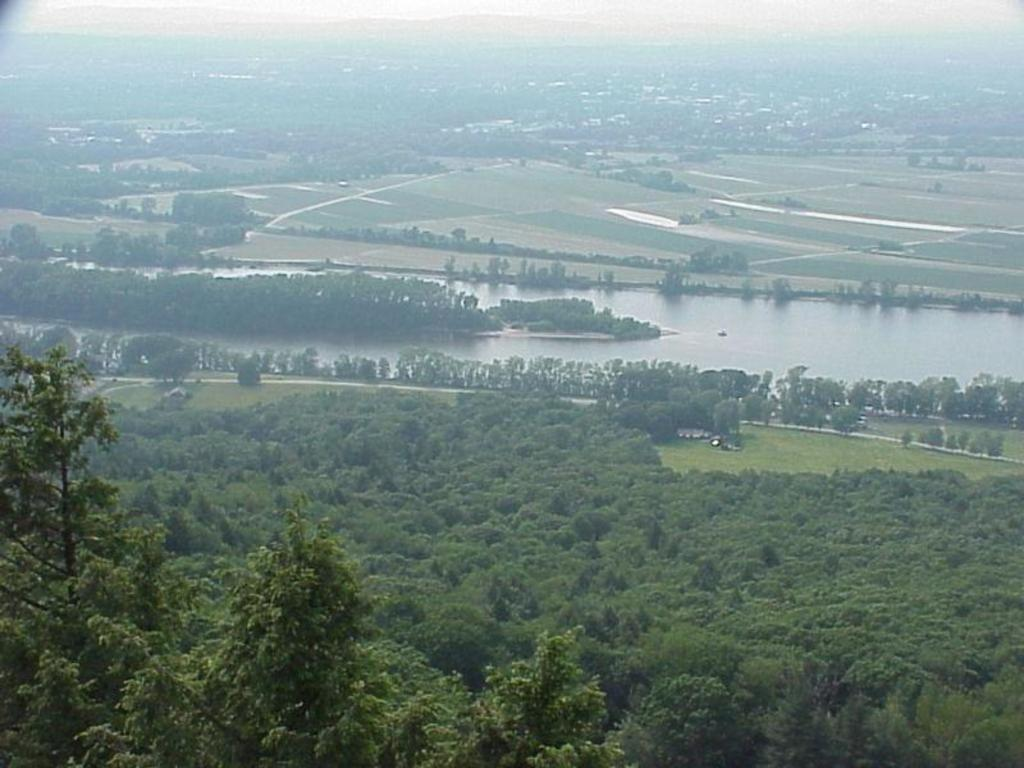What type of vegetation can be seen in the image? There are many trees in the image. What else can be seen besides trees in the image? There is water and grass visible in the image. What is the ground made of in the image? The ground is visible in the image. What flavor of education is being taught in the image? There is no reference to education or any learning activity in the image, so it's not possible to determine the flavor of education being taught. 